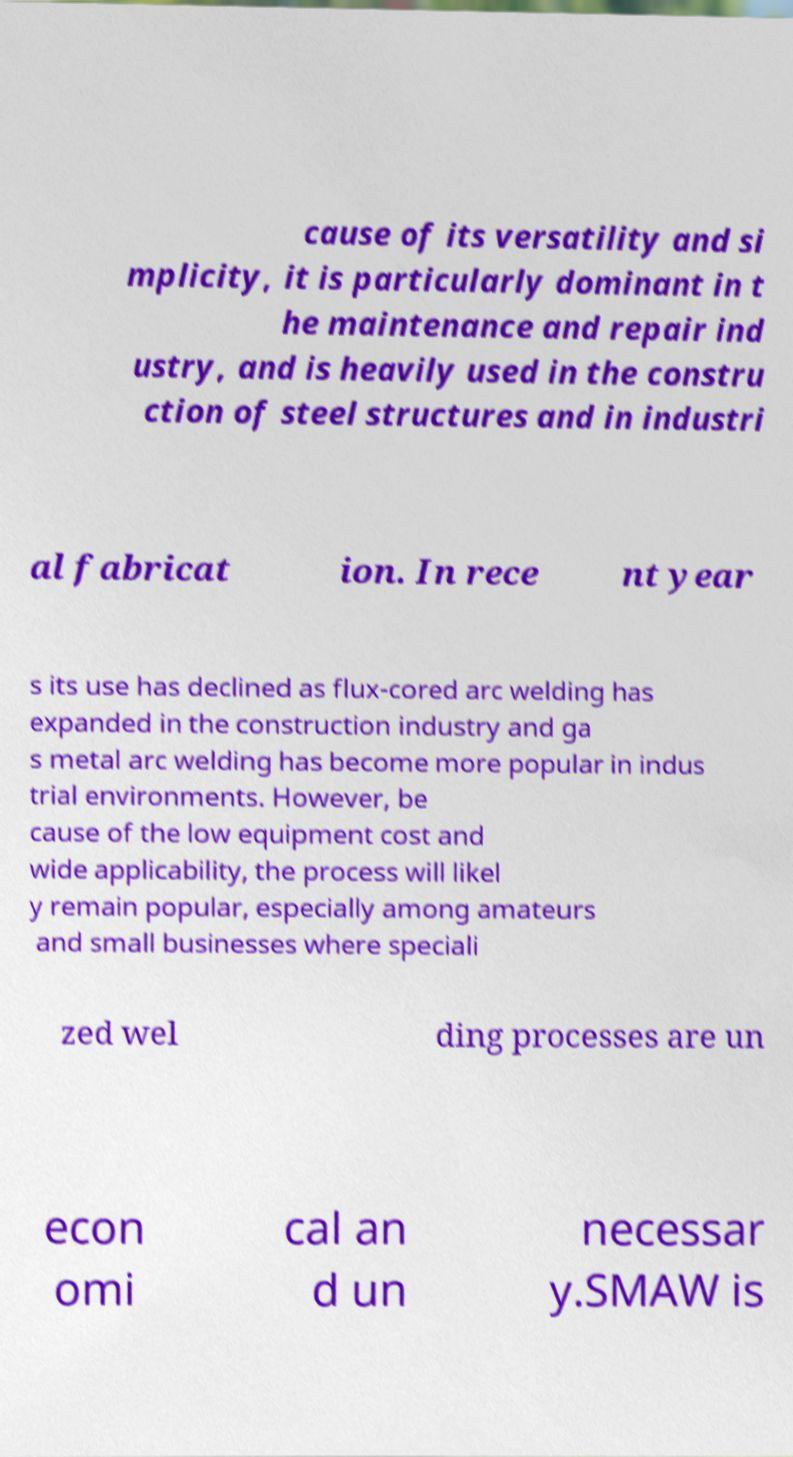Could you extract and type out the text from this image? cause of its versatility and si mplicity, it is particularly dominant in t he maintenance and repair ind ustry, and is heavily used in the constru ction of steel structures and in industri al fabricat ion. In rece nt year s its use has declined as flux-cored arc welding has expanded in the construction industry and ga s metal arc welding has become more popular in indus trial environments. However, be cause of the low equipment cost and wide applicability, the process will likel y remain popular, especially among amateurs and small businesses where speciali zed wel ding processes are un econ omi cal an d un necessar y.SMAW is 